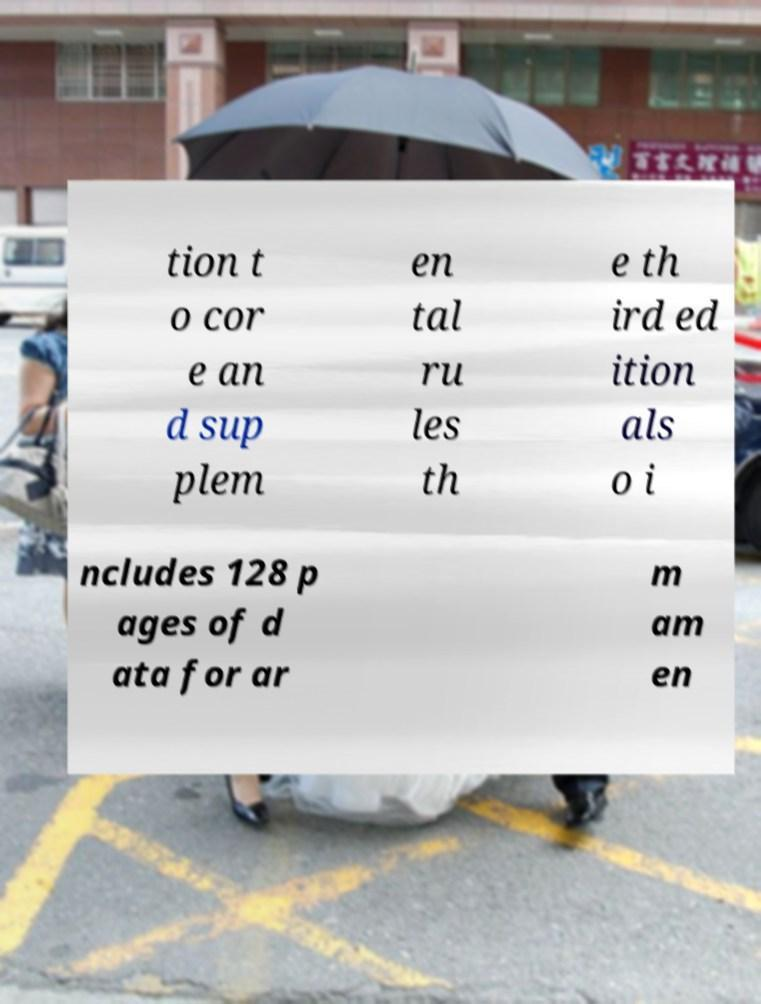There's text embedded in this image that I need extracted. Can you transcribe it verbatim? tion t o cor e an d sup plem en tal ru les th e th ird ed ition als o i ncludes 128 p ages of d ata for ar m am en 